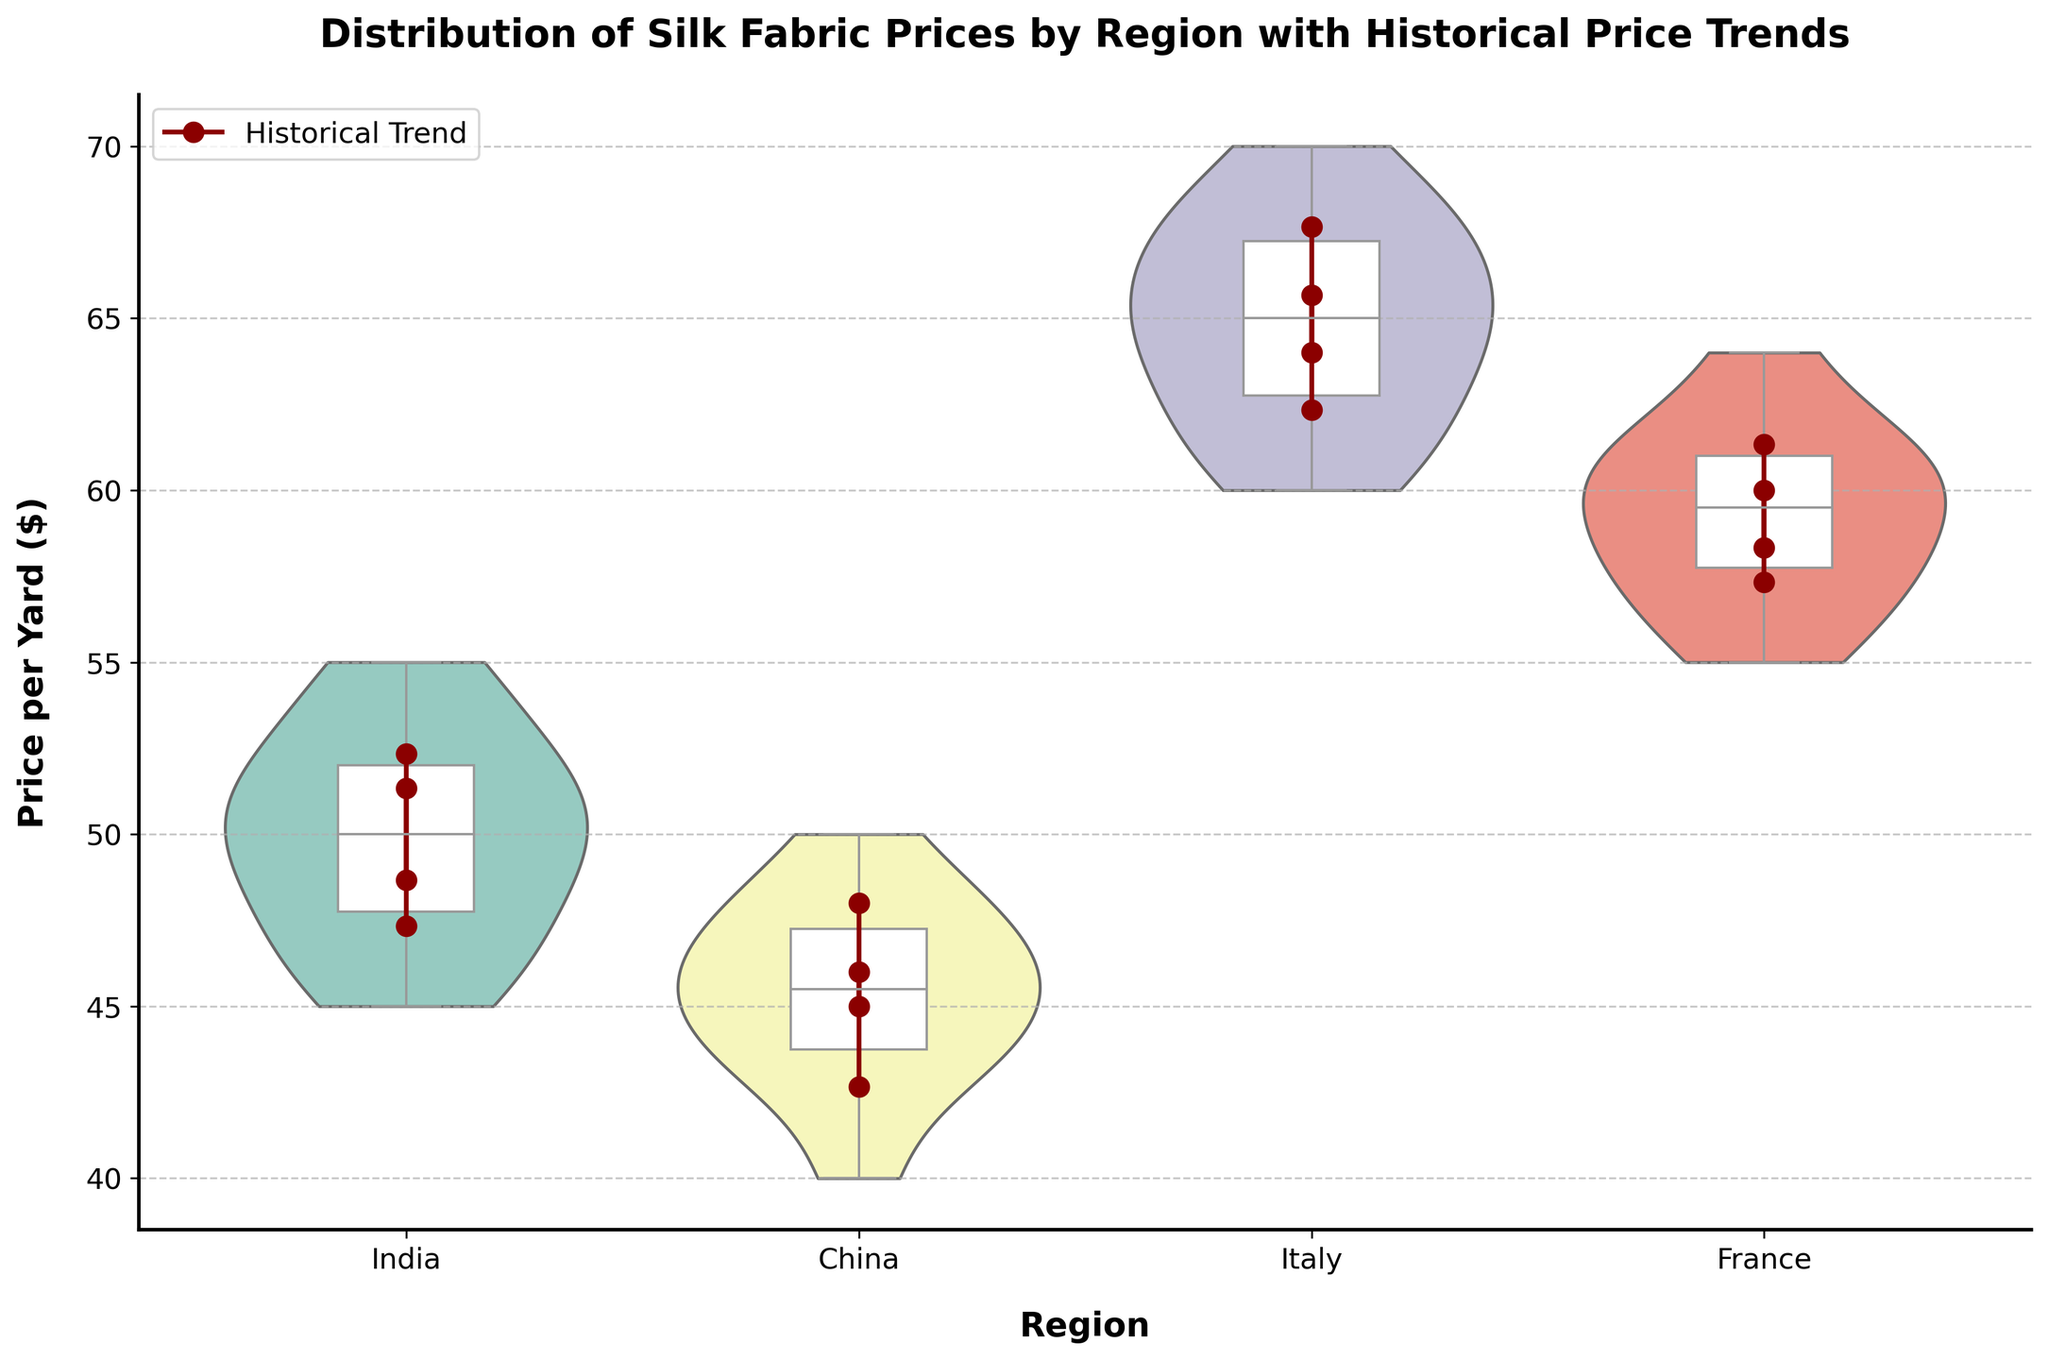What is the title of the plot? The title of the plot is displayed at the top and describes the main focus of the visualization. It reads "Distribution of Silk Fabric Prices by Region with Historical Price Trends".
Answer: Distribution of Silk Fabric Prices by Region with Historical Price Trends How many regions are represented in the plot? By counting the unique categories on the x-axis, we can see that there are four regions represented in the plot: India, China, Italy, and France.
Answer: 4 Which region has the highest median price for silk fabric in the dataset? The box plot overlays the violins, showing the median with a horizontal line. By examining the medians, we can see that Italy has the highest median price per yard of silk fabric.
Answer: Italy How does the price trend for China compare to that for France from 2018 to 2021? The trend lines, represented by dark red lines, allow us to compare price developments for each region. China's prices generally increase from 40 to 50 over the years, while France also shows an increasing trend from 55 to 64. Both regions show an upward price trend over these years.
Answer: Both have increasing trends What is the range of prices for India in the year 2020? For India in 2020, refer to the violin and box plot where prices range from about 46 to 51 per yard.
Answer: 46 to 51 Which region shows the smallest variation in silk fabric prices? The width of the violin plots represents the distribution density. China has the most compact violin, indicating the smallest variation in prices.
Answer: China Which year had the highest average silk fabric price for Italy? The dark red trend lines with markers indicate average prices per year. For Italy, the highest average price is observed in 2021, where the line peaks around 68.
Answer: 2021 Is the median price for France in 2021 higher or lower than the average price for China in 2020? The horizontal line in the box plot section of France for 2021 marks the median, which is at 61. The dark red dot for China in 2020 shows an average price of about 45. Therefore, the median price for France in 2021 is higher.
Answer: Higher What is the interquartile range (IQR) for the silk prices in France in 2019? The IQR is the range between the first quartile (Q1) and the third quartile (Q3) within the box plot. For France in 2019, Q1 is approximately 58 and Q3 is approximately 62, making the IQR 62 - 58.
Answer: 4 